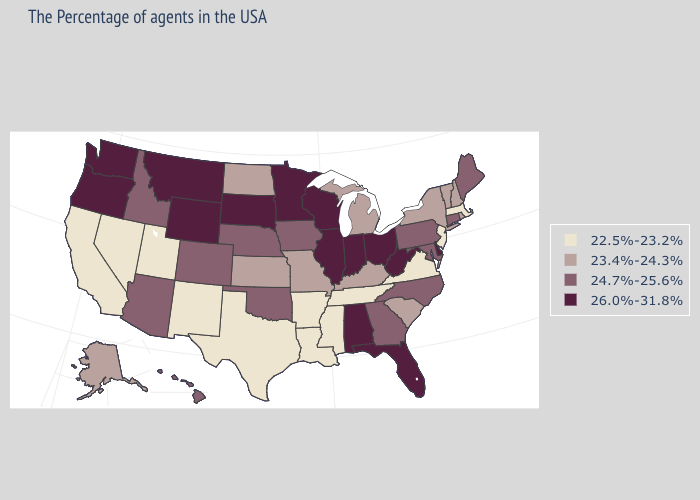What is the value of Washington?
Keep it brief. 26.0%-31.8%. Name the states that have a value in the range 24.7%-25.6%?
Short answer required. Maine, Connecticut, Maryland, Pennsylvania, North Carolina, Georgia, Iowa, Nebraska, Oklahoma, Colorado, Arizona, Idaho, Hawaii. What is the value of Indiana?
Write a very short answer. 26.0%-31.8%. Which states have the highest value in the USA?
Be succinct. Delaware, West Virginia, Ohio, Florida, Indiana, Alabama, Wisconsin, Illinois, Minnesota, South Dakota, Wyoming, Montana, Washington, Oregon. Name the states that have a value in the range 26.0%-31.8%?
Write a very short answer. Delaware, West Virginia, Ohio, Florida, Indiana, Alabama, Wisconsin, Illinois, Minnesota, South Dakota, Wyoming, Montana, Washington, Oregon. What is the highest value in the USA?
Concise answer only. 26.0%-31.8%. What is the highest value in the West ?
Write a very short answer. 26.0%-31.8%. Name the states that have a value in the range 26.0%-31.8%?
Short answer required. Delaware, West Virginia, Ohio, Florida, Indiana, Alabama, Wisconsin, Illinois, Minnesota, South Dakota, Wyoming, Montana, Washington, Oregon. Which states have the highest value in the USA?
Write a very short answer. Delaware, West Virginia, Ohio, Florida, Indiana, Alabama, Wisconsin, Illinois, Minnesota, South Dakota, Wyoming, Montana, Washington, Oregon. What is the value of Massachusetts?
Keep it brief. 22.5%-23.2%. What is the value of Hawaii?
Short answer required. 24.7%-25.6%. Name the states that have a value in the range 22.5%-23.2%?
Give a very brief answer. Massachusetts, New Jersey, Virginia, Tennessee, Mississippi, Louisiana, Arkansas, Texas, New Mexico, Utah, Nevada, California. What is the value of Iowa?
Answer briefly. 24.7%-25.6%. What is the value of West Virginia?
Short answer required. 26.0%-31.8%. Which states have the lowest value in the USA?
Write a very short answer. Massachusetts, New Jersey, Virginia, Tennessee, Mississippi, Louisiana, Arkansas, Texas, New Mexico, Utah, Nevada, California. 